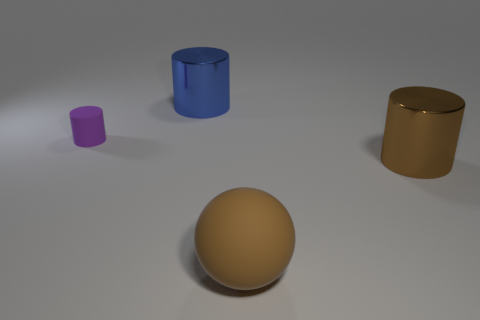Can you describe the lighting and shadows in the image? The lighting in the image is soft and diffused, coming from the upper left, casting subtle shadows on the right side of the objects, which helps to give a sense of depth and form to the scene. 